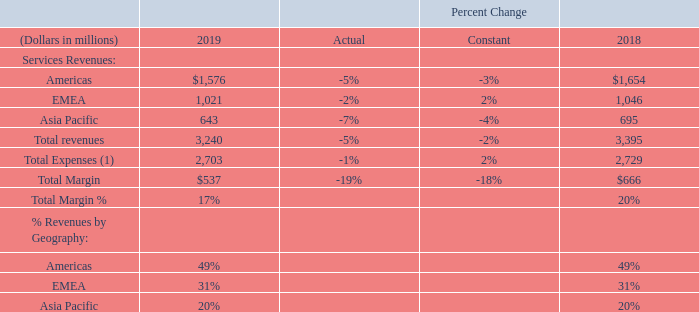Services Business
We offer services to customers and partners to help to maximize the performance of their investments in Oracle applications and infrastructure technologies. Services revenues are generally recognized as the services are performed. The cost of providing our services consists primarily of personnel related expenses, technology infrastructure expenditures, facilities expenses and external contractor expenses.
(1) Excludes stock-based compensation and certain expense allocations. Also excludes amortization of intangible assets and certain other GAAP-based expenses, which were not allocated to our operating segment results for purposes of reporting to and review by our CODMs, as further described under “Presentation of Operating Segments and Other Financial Information” above.
Excluding the effects of currency rate fluctuations, our total services revenues decreased in fiscal 2019 relative to fiscal 2018 primarily due to revenue declines in our education services and, to a lesser extent, our consulting services. During fiscal 2019, constant currency increases in our EMEA-based services revenues were offset by constant currency services revenue decreases in the Americas and the Asia Pacific regions.
In constant currency, total services expenses increased in fiscal 2019 compared to fiscal 2018 primarily due to an increase in employee related expenses and external contractor expenses associated with investments in our consulting services that support our cloud offerings. In constant currency, total margin and total margin as a percentage of total services revenues decreased during fiscal 2019 relative to fiscal 2018 due to decreased revenues and increased expenses for this business.
By how much less did the company make in services revenues in 2019 compared to 2018?
Answer scale should be: million. 3,395 - 3,240 
Answer: 155. How much less was the total margin in 2019 then in 2018?
Answer scale should be: million. 666-537 
Answer: 129. What was the difference in percentage revenues by geography in the EMEA relative to the Asia Pacific in 2019?
Answer scale should be: million. 31-20 
Answer: 11. How much was the constant percentage change and the actual percentage change in total expenses?
Answer scale should be: percent. 2%, -1%. What make up the company's cost of providing services? The cost of providing our services consists primarily of personnel related expenses, technology infrastructure expenditures, facilities expenses and external contractor expenses. Why did the total services revenue decrease in fiscal 2019 relative to fiscal 2018? Excluding the effects of currency rate fluctuations, our total services revenues decreased in fiscal 2019 relative to fiscal 2018 primarily due to revenue declines in our education services and, to a lesser extent, our consulting services. 